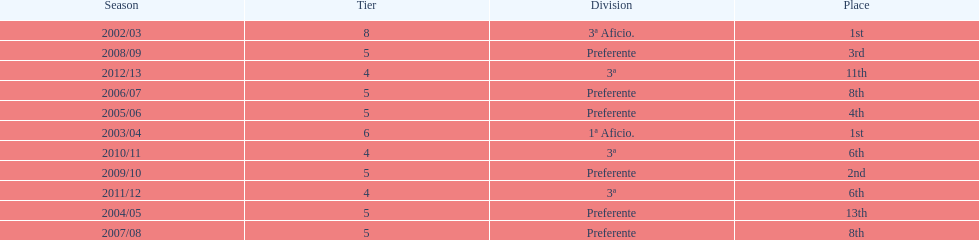What was the number of wins for preferente? 6. 